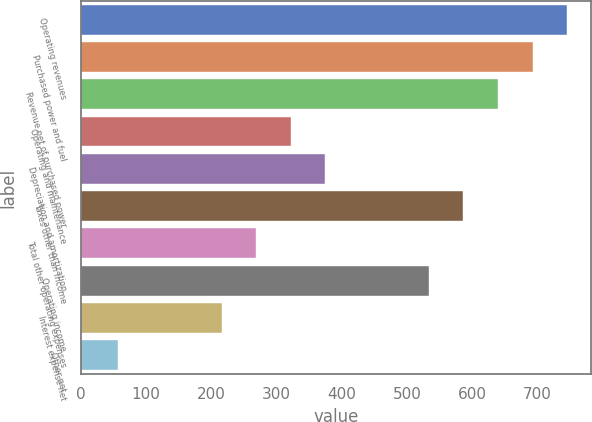Convert chart. <chart><loc_0><loc_0><loc_500><loc_500><bar_chart><fcel>Operating revenues<fcel>Purchased power and fuel<fcel>Revenue net of purchased power<fcel>Operating and maintenance<fcel>Depreciation and amortization<fcel>Taxes other than income<fcel>Total other operating expenses<fcel>Operating income<fcel>Interest expense net<fcel>Other net<nl><fcel>745.6<fcel>692.7<fcel>639.8<fcel>322.4<fcel>375.3<fcel>586.9<fcel>269.5<fcel>534<fcel>216.6<fcel>57.9<nl></chart> 